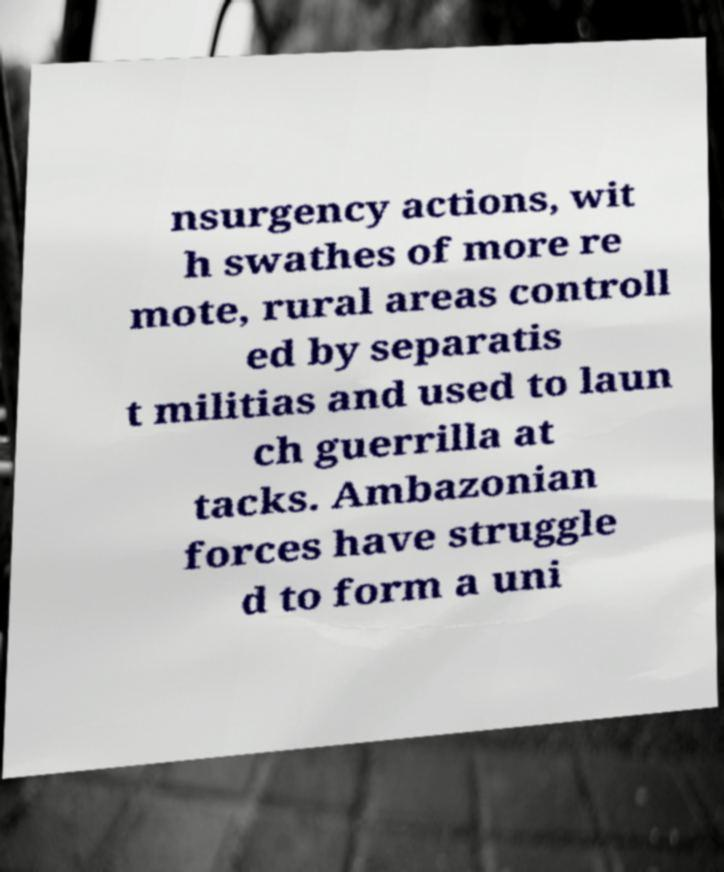Please read and relay the text visible in this image. What does it say? nsurgency actions, wit h swathes of more re mote, rural areas controll ed by separatis t militias and used to laun ch guerrilla at tacks. Ambazonian forces have struggle d to form a uni 